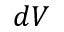Convert formula to latex. <formula><loc_0><loc_0><loc_500><loc_500>d V</formula> 